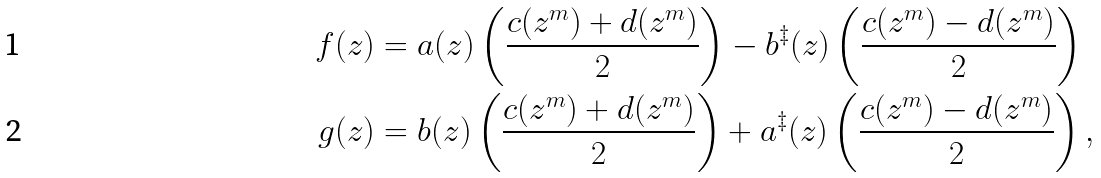<formula> <loc_0><loc_0><loc_500><loc_500>f ( z ) & = a ( z ) \left ( \frac { c ( z ^ { m } ) + d ( z ^ { m } ) } { 2 } \right ) - b ^ { \ddag } ( z ) \left ( \frac { c ( z ^ { m } ) - d ( z ^ { m } ) } { 2 } \right ) \\ g ( z ) & = b ( z ) \left ( \frac { c ( z ^ { m } ) + d ( z ^ { m } ) } { 2 } \right ) + a ^ { \ddag } ( z ) \left ( \frac { c ( z ^ { m } ) - d ( z ^ { m } ) } { 2 } \right ) ,</formula> 